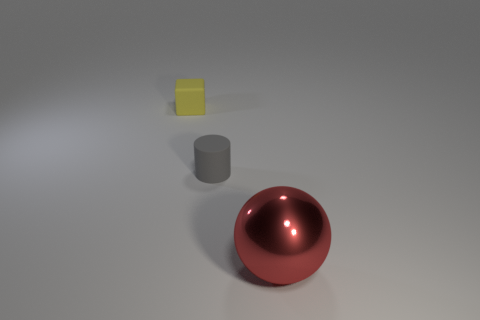Add 2 small yellow rubber objects. How many objects exist? 5 Subtract all balls. How many objects are left? 2 Add 1 tiny yellow rubber cubes. How many tiny yellow rubber cubes are left? 2 Add 1 big red metal objects. How many big red metal objects exist? 2 Subtract 0 brown blocks. How many objects are left? 3 Subtract all tiny brown things. Subtract all small things. How many objects are left? 1 